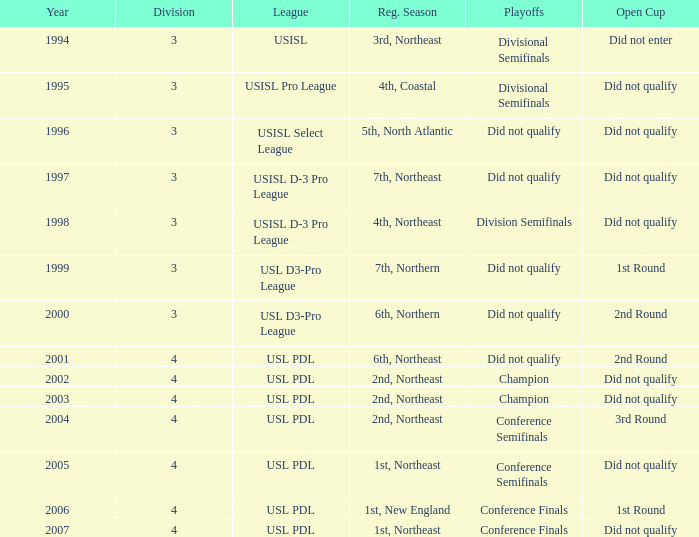Name the number of playoffs for 3rd round 1.0. 